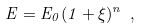Convert formula to latex. <formula><loc_0><loc_0><loc_500><loc_500>E = E _ { 0 } ( 1 + \xi ) ^ { n } \ ,</formula> 